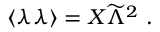Convert formula to latex. <formula><loc_0><loc_0><loc_500><loc_500>\langle \lambda \lambda \rangle = X { \widetilde { \Lambda } } ^ { 2 } .</formula> 